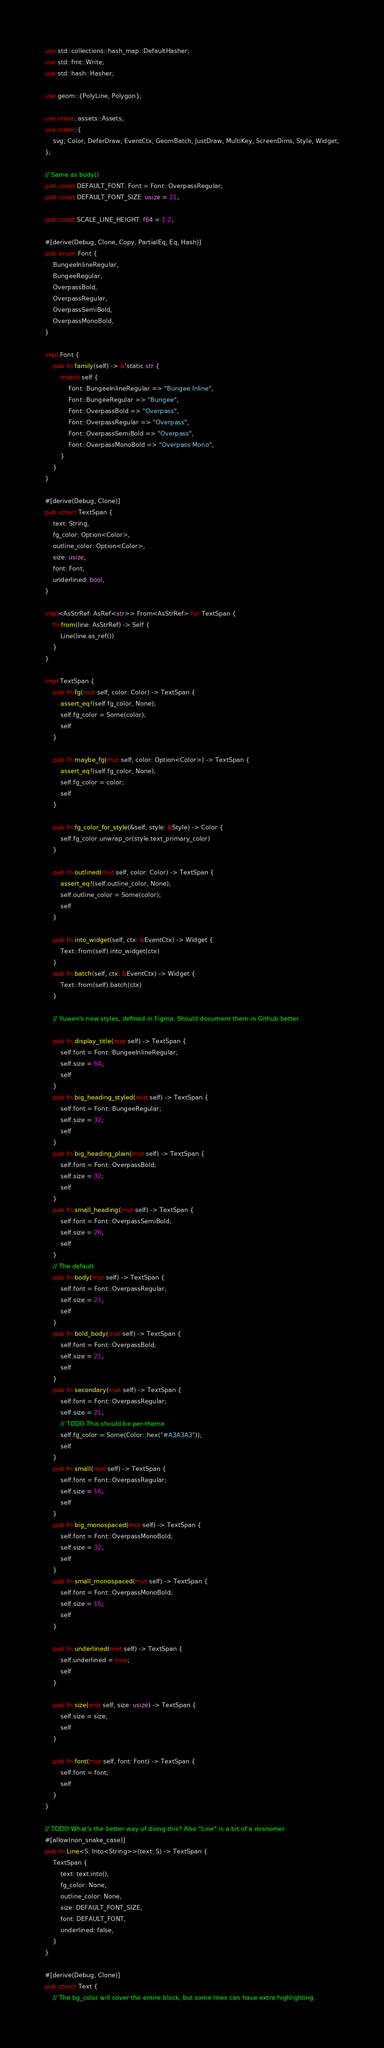Convert code to text. <code><loc_0><loc_0><loc_500><loc_500><_Rust_>use std::collections::hash_map::DefaultHasher;
use std::fmt::Write;
use std::hash::Hasher;

use geom::{PolyLine, Polygon};

use crate::assets::Assets;
use crate::{
    svg, Color, DeferDraw, EventCtx, GeomBatch, JustDraw, MultiKey, ScreenDims, Style, Widget,
};

// Same as body()
pub const DEFAULT_FONT: Font = Font::OverpassRegular;
pub const DEFAULT_FONT_SIZE: usize = 21;

pub const SCALE_LINE_HEIGHT: f64 = 1.2;

#[derive(Debug, Clone, Copy, PartialEq, Eq, Hash)]
pub enum Font {
    BungeeInlineRegular,
    BungeeRegular,
    OverpassBold,
    OverpassRegular,
    OverpassSemiBold,
    OverpassMonoBold,
}

impl Font {
    pub fn family(self) -> &'static str {
        match self {
            Font::BungeeInlineRegular => "Bungee Inline",
            Font::BungeeRegular => "Bungee",
            Font::OverpassBold => "Overpass",
            Font::OverpassRegular => "Overpass",
            Font::OverpassSemiBold => "Overpass",
            Font::OverpassMonoBold => "Overpass Mono",
        }
    }
}

#[derive(Debug, Clone)]
pub struct TextSpan {
    text: String,
    fg_color: Option<Color>,
    outline_color: Option<Color>,
    size: usize,
    font: Font,
    underlined: bool,
}

impl<AsStrRef: AsRef<str>> From<AsStrRef> for TextSpan {
    fn from(line: AsStrRef) -> Self {
        Line(line.as_ref())
    }
}

impl TextSpan {
    pub fn fg(mut self, color: Color) -> TextSpan {
        assert_eq!(self.fg_color, None);
        self.fg_color = Some(color);
        self
    }

    pub fn maybe_fg(mut self, color: Option<Color>) -> TextSpan {
        assert_eq!(self.fg_color, None);
        self.fg_color = color;
        self
    }

    pub fn fg_color_for_style(&self, style: &Style) -> Color {
        self.fg_color.unwrap_or(style.text_primary_color)
    }

    pub fn outlined(mut self, color: Color) -> TextSpan {
        assert_eq!(self.outline_color, None);
        self.outline_color = Some(color);
        self
    }

    pub fn into_widget(self, ctx: &EventCtx) -> Widget {
        Text::from(self).into_widget(ctx)
    }
    pub fn batch(self, ctx: &EventCtx) -> Widget {
        Text::from(self).batch(ctx)
    }

    // Yuwen's new styles, defined in Figma. Should document them in Github better.

    pub fn display_title(mut self) -> TextSpan {
        self.font = Font::BungeeInlineRegular;
        self.size = 64;
        self
    }
    pub fn big_heading_styled(mut self) -> TextSpan {
        self.font = Font::BungeeRegular;
        self.size = 32;
        self
    }
    pub fn big_heading_plain(mut self) -> TextSpan {
        self.font = Font::OverpassBold;
        self.size = 32;
        self
    }
    pub fn small_heading(mut self) -> TextSpan {
        self.font = Font::OverpassSemiBold;
        self.size = 26;
        self
    }
    // The default
    pub fn body(mut self) -> TextSpan {
        self.font = Font::OverpassRegular;
        self.size = 21;
        self
    }
    pub fn bold_body(mut self) -> TextSpan {
        self.font = Font::OverpassBold;
        self.size = 21;
        self
    }
    pub fn secondary(mut self) -> TextSpan {
        self.font = Font::OverpassRegular;
        self.size = 21;
        // TODO This should be per-theme
        self.fg_color = Some(Color::hex("#A3A3A3"));
        self
    }
    pub fn small(mut self) -> TextSpan {
        self.font = Font::OverpassRegular;
        self.size = 16;
        self
    }
    pub fn big_monospaced(mut self) -> TextSpan {
        self.font = Font::OverpassMonoBold;
        self.size = 32;
        self
    }
    pub fn small_monospaced(mut self) -> TextSpan {
        self.font = Font::OverpassMonoBold;
        self.size = 16;
        self
    }

    pub fn underlined(mut self) -> TextSpan {
        self.underlined = true;
        self
    }

    pub fn size(mut self, size: usize) -> TextSpan {
        self.size = size;
        self
    }

    pub fn font(mut self, font: Font) -> TextSpan {
        self.font = font;
        self
    }
}

// TODO What's the better way of doing this? Also "Line" is a bit of a misnomer
#[allow(non_snake_case)]
pub fn Line<S: Into<String>>(text: S) -> TextSpan {
    TextSpan {
        text: text.into(),
        fg_color: None,
        outline_color: None,
        size: DEFAULT_FONT_SIZE,
        font: DEFAULT_FONT,
        underlined: false,
    }
}

#[derive(Debug, Clone)]
pub struct Text {
    // The bg_color will cover the entire block, but some lines can have extra highlighting.</code> 